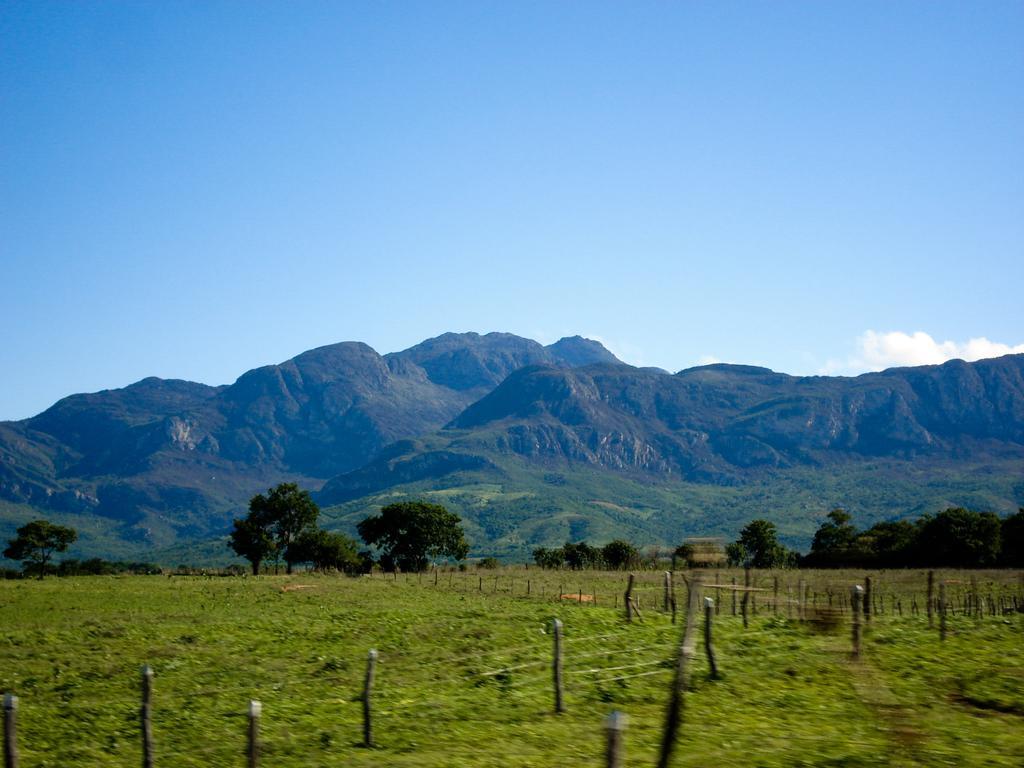How would you summarize this image in a sentence or two? In the image we can see this is a grass, trees, mountain and a sky. These are the poles. 